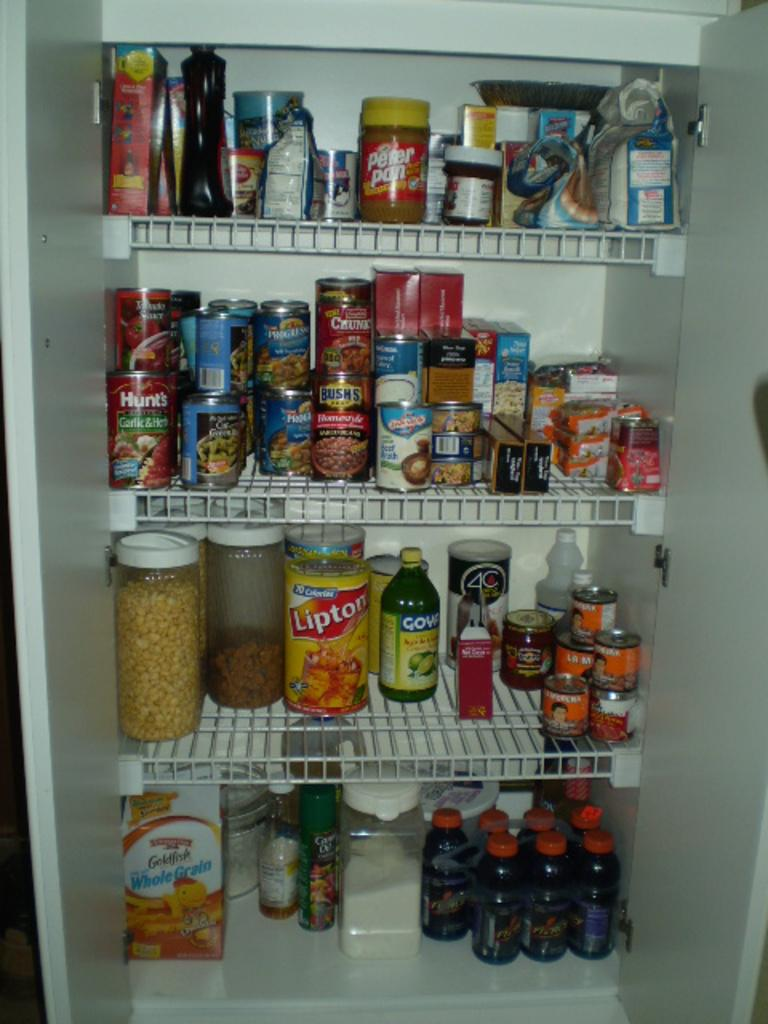<image>
Offer a succinct explanation of the picture presented. a pantry with lipton tea and hunts tomato sauce 